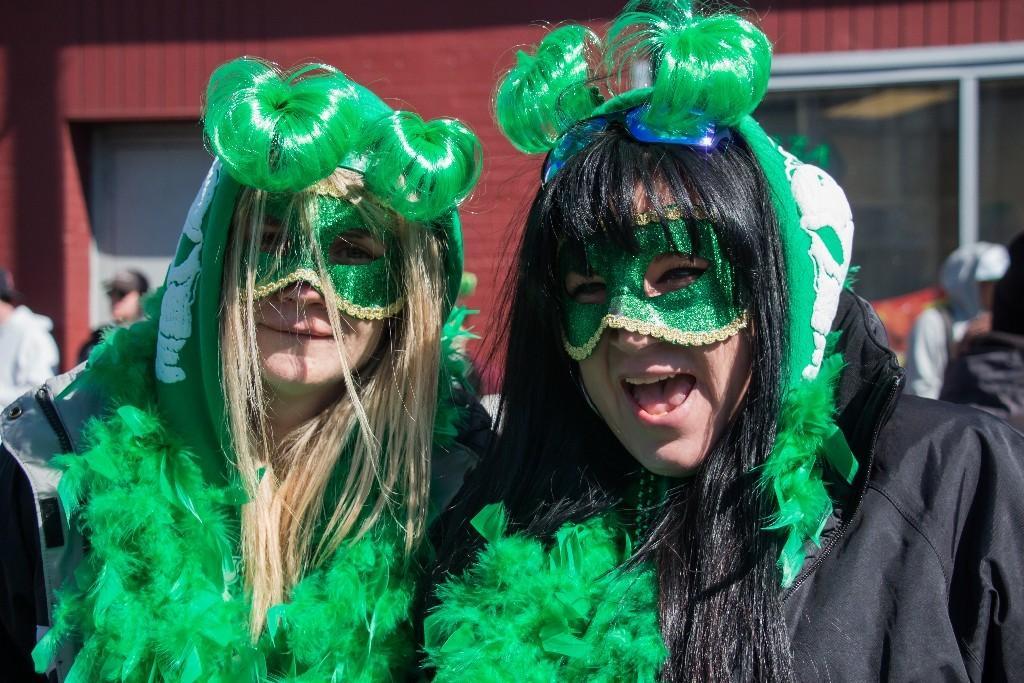Describe this image in one or two sentences. In this image we can see two persons wearing costume and they both are wearing mask to their face and posing for a photo. We can see few people and there is a building in the background. 